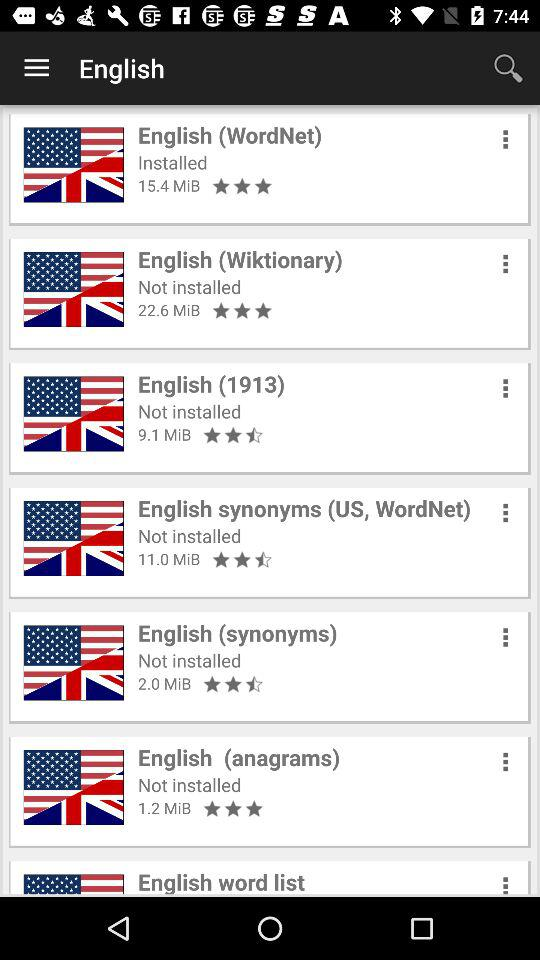How much memory space is consumed by "English (synonyms)"? It consumes 2.0 MiB. 